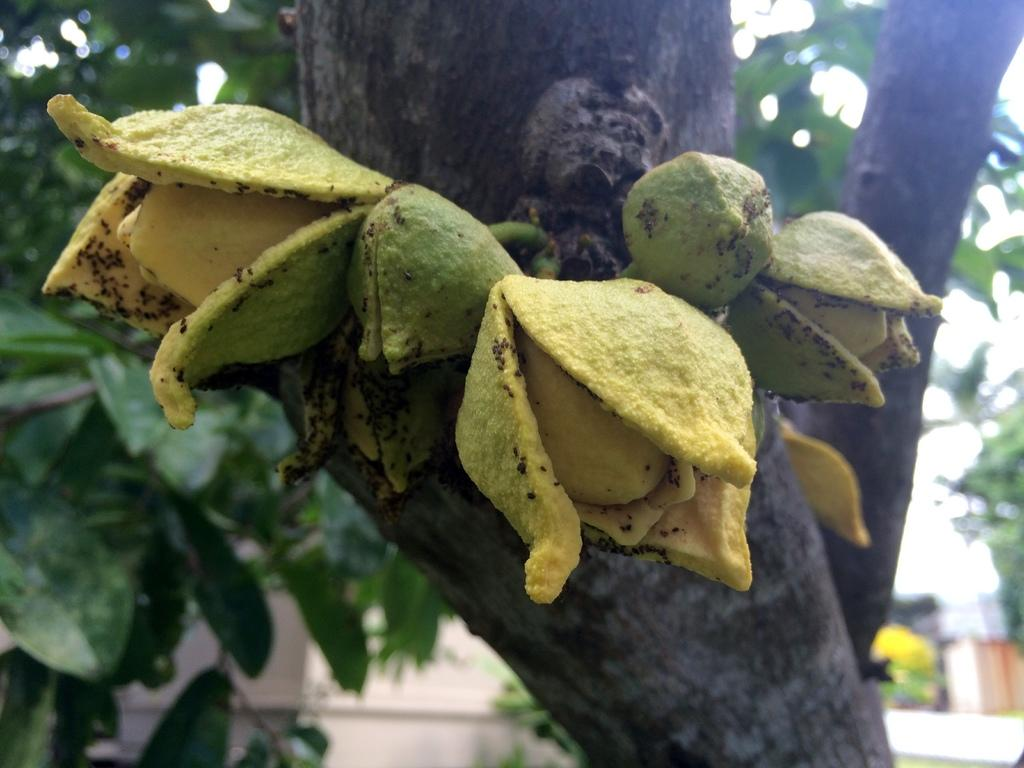What is placed on the trunk in the image? There are fruits on a trunk in the image. What colors can be seen on the fruits? The fruits are in yellow and green colors. Can you describe the background of the image? The background of the image is blurred. What type of insect can be seen crawling on the books in the image? There are no books or insects present in the image; it features fruits on a trunk with a blurred background. 